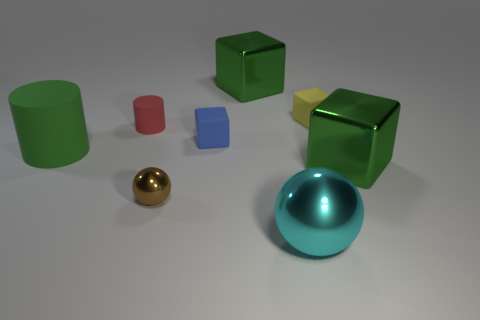How many green cubes must be subtracted to get 1 green cubes? 1 Subtract 2 cubes. How many cubes are left? 2 Add 2 big cyan balls. How many objects exist? 10 Subtract all cylinders. How many objects are left? 6 Subtract 0 brown cylinders. How many objects are left? 8 Subtract all big blue objects. Subtract all red cylinders. How many objects are left? 7 Add 3 red objects. How many red objects are left? 4 Add 4 tiny red matte cylinders. How many tiny red matte cylinders exist? 5 